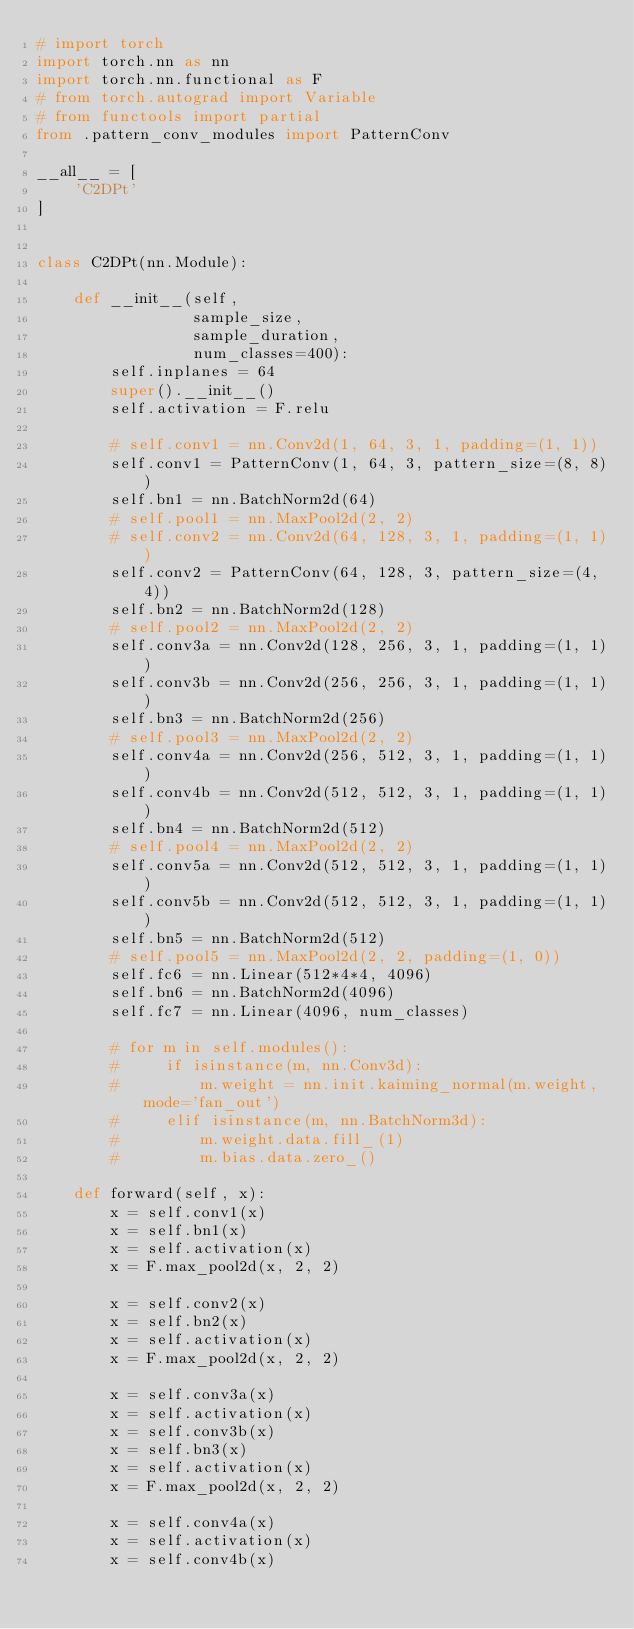Convert code to text. <code><loc_0><loc_0><loc_500><loc_500><_Python_># import torch
import torch.nn as nn
import torch.nn.functional as F
# from torch.autograd import Variable
# from functools import partial
from .pattern_conv_modules import PatternConv

__all__ = [
    'C2DPt'
]


class C2DPt(nn.Module):

    def __init__(self,
                 sample_size,
                 sample_duration,
                 num_classes=400):
        self.inplanes = 64
        super().__init__()
        self.activation = F.relu

        # self.conv1 = nn.Conv2d(1, 64, 3, 1, padding=(1, 1))
        self.conv1 = PatternConv(1, 64, 3, pattern_size=(8, 8))
        self.bn1 = nn.BatchNorm2d(64)
        # self.pool1 = nn.MaxPool2d(2, 2)
        # self.conv2 = nn.Conv2d(64, 128, 3, 1, padding=(1, 1))
        self.conv2 = PatternConv(64, 128, 3, pattern_size=(4, 4))
        self.bn2 = nn.BatchNorm2d(128)
        # self.pool2 = nn.MaxPool2d(2, 2)
        self.conv3a = nn.Conv2d(128, 256, 3, 1, padding=(1, 1))
        self.conv3b = nn.Conv2d(256, 256, 3, 1, padding=(1, 1))
        self.bn3 = nn.BatchNorm2d(256)
        # self.pool3 = nn.MaxPool2d(2, 2)
        self.conv4a = nn.Conv2d(256, 512, 3, 1, padding=(1, 1))
        self.conv4b = nn.Conv2d(512, 512, 3, 1, padding=(1, 1))
        self.bn4 = nn.BatchNorm2d(512)
        # self.pool4 = nn.MaxPool2d(2, 2)
        self.conv5a = nn.Conv2d(512, 512, 3, 1, padding=(1, 1))
        self.conv5b = nn.Conv2d(512, 512, 3, 1, padding=(1, 1))
        self.bn5 = nn.BatchNorm2d(512)
        # self.pool5 = nn.MaxPool2d(2, 2, padding=(1, 0))
        self.fc6 = nn.Linear(512*4*4, 4096)
        self.bn6 = nn.BatchNorm2d(4096)
        self.fc7 = nn.Linear(4096, num_classes)

        # for m in self.modules():
        #     if isinstance(m, nn.Conv3d):
        #         m.weight = nn.init.kaiming_normal(m.weight, mode='fan_out')
        #     elif isinstance(m, nn.BatchNorm3d):
        #         m.weight.data.fill_(1)
        #         m.bias.data.zero_()

    def forward(self, x):
        x = self.conv1(x)
        x = self.bn1(x)
        x = self.activation(x)
        x = F.max_pool2d(x, 2, 2)

        x = self.conv2(x)
        x = self.bn2(x)
        x = self.activation(x)
        x = F.max_pool2d(x, 2, 2)

        x = self.conv3a(x)
        x = self.activation(x)
        x = self.conv3b(x)
        x = self.bn3(x)
        x = self.activation(x)
        x = F.max_pool2d(x, 2, 2)

        x = self.conv4a(x)
        x = self.activation(x)
        x = self.conv4b(x)</code> 